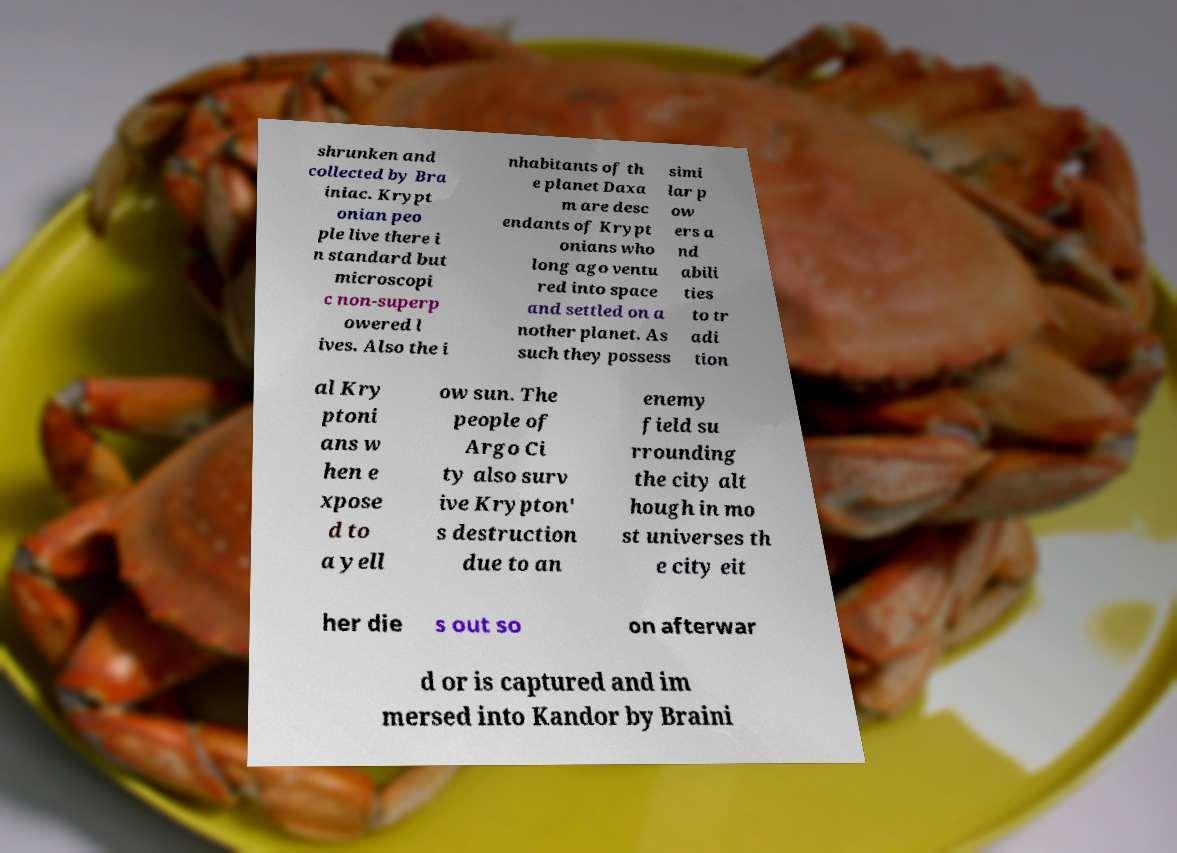Can you read and provide the text displayed in the image?This photo seems to have some interesting text. Can you extract and type it out for me? shrunken and collected by Bra iniac. Krypt onian peo ple live there i n standard but microscopi c non-superp owered l ives. Also the i nhabitants of th e planet Daxa m are desc endants of Krypt onians who long ago ventu red into space and settled on a nother planet. As such they possess simi lar p ow ers a nd abili ties to tr adi tion al Kry ptoni ans w hen e xpose d to a yell ow sun. The people of Argo Ci ty also surv ive Krypton' s destruction due to an enemy field su rrounding the city alt hough in mo st universes th e city eit her die s out so on afterwar d or is captured and im mersed into Kandor by Braini 